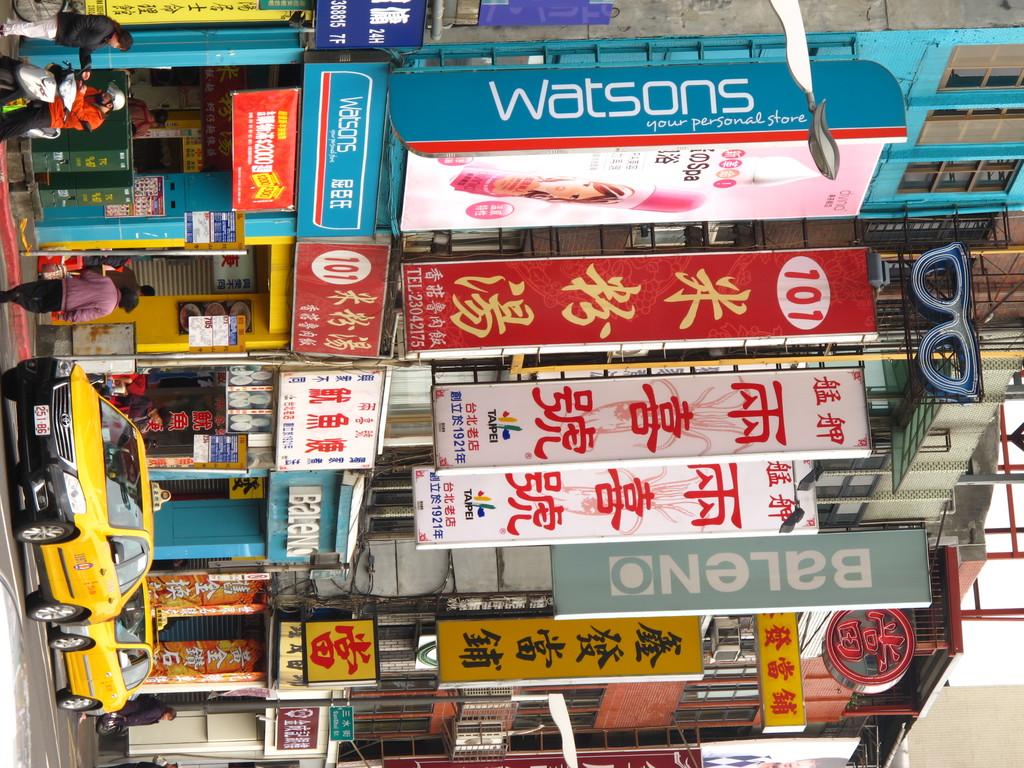What is the brand name on the blue banner at the top of the image?
Offer a terse response. Watsons. What number is on the red banner?
Ensure brevity in your answer.  101. 